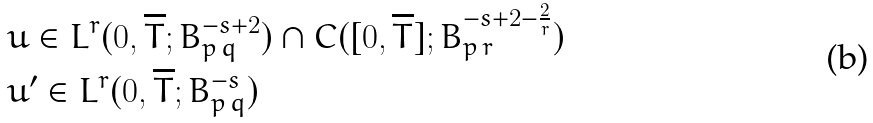<formula> <loc_0><loc_0><loc_500><loc_500>& u \in L ^ { r } ( 0 , \overline { T } ; B ^ { - s + 2 } _ { p \, q } ) \cap C ( [ 0 , \overline { T } ] ; B ^ { - s + 2 - \frac { 2 } { r } } _ { p \, r } ) \\ & u ^ { \prime } \in L ^ { r } ( 0 , \overline { T } ; B ^ { - s } _ { p \, q } )</formula> 